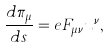Convert formula to latex. <formula><loc_0><loc_0><loc_500><loc_500>\frac { d \pi _ { \mu } } { d s } = e F _ { \mu \nu } u ^ { \nu } ,</formula> 